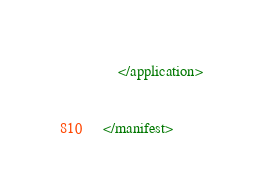<code> <loc_0><loc_0><loc_500><loc_500><_XML_>
	</application>


</manifest> </code> 